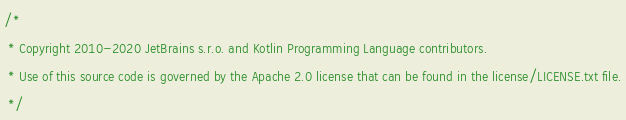<code> <loc_0><loc_0><loc_500><loc_500><_Kotlin_>/*
 * Copyright 2010-2020 JetBrains s.r.o. and Kotlin Programming Language contributors.
 * Use of this source code is governed by the Apache 2.0 license that can be found in the license/LICENSE.txt file.
 */
</code> 